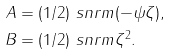Convert formula to latex. <formula><loc_0><loc_0><loc_500><loc_500>A & = ( 1 / 2 ) \ s n r m { ( - \psi \zeta ) } , \\ B & = ( 1 / 2 ) \ s n r m { \zeta ^ { 2 } } .</formula> 